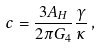Convert formula to latex. <formula><loc_0><loc_0><loc_500><loc_500>c = \frac { 3 A _ { H } } { 2 \pi G _ { 4 } } \frac { \gamma } { \kappa } \, ,</formula> 